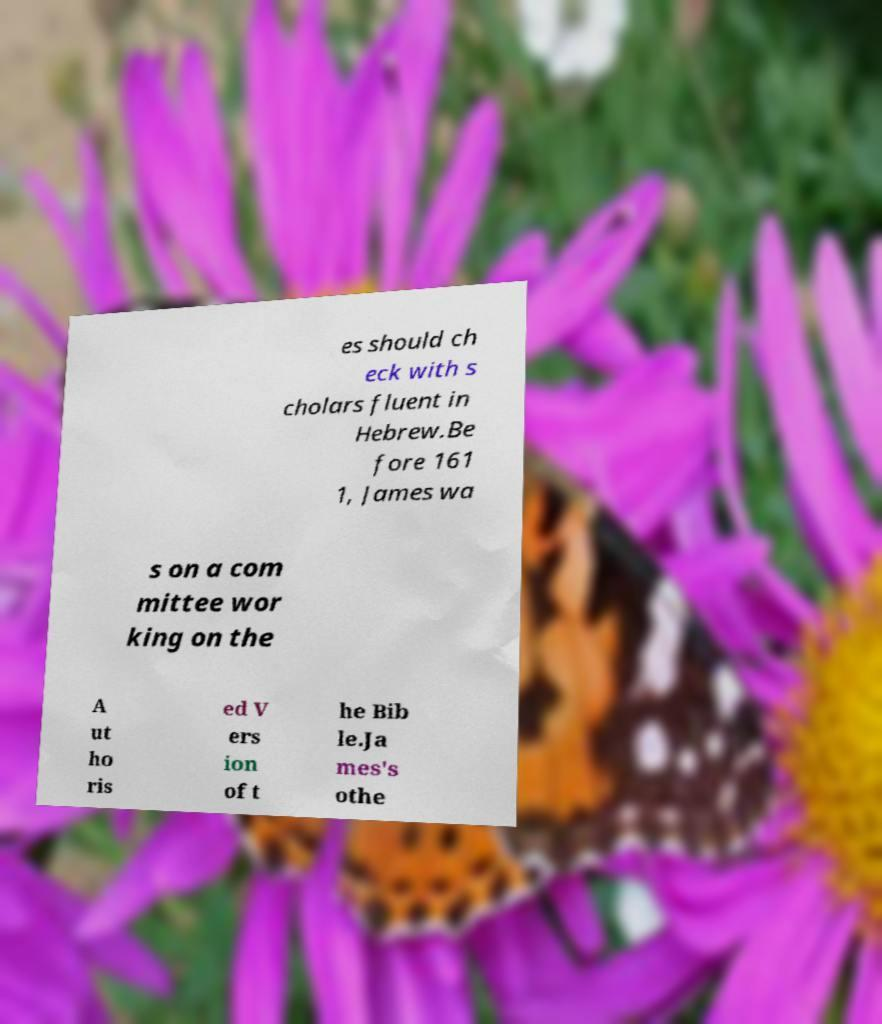Could you assist in decoding the text presented in this image and type it out clearly? es should ch eck with s cholars fluent in Hebrew.Be fore 161 1, James wa s on a com mittee wor king on the A ut ho ris ed V ers ion of t he Bib le.Ja mes's othe 